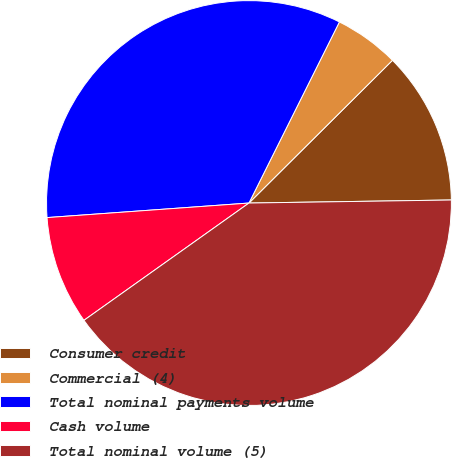Convert chart. <chart><loc_0><loc_0><loc_500><loc_500><pie_chart><fcel>Consumer credit<fcel>Commercial (4)<fcel>Total nominal payments volume<fcel>Cash volume<fcel>Total nominal volume (5)<nl><fcel>12.22%<fcel>5.17%<fcel>33.52%<fcel>8.69%<fcel>40.41%<nl></chart> 